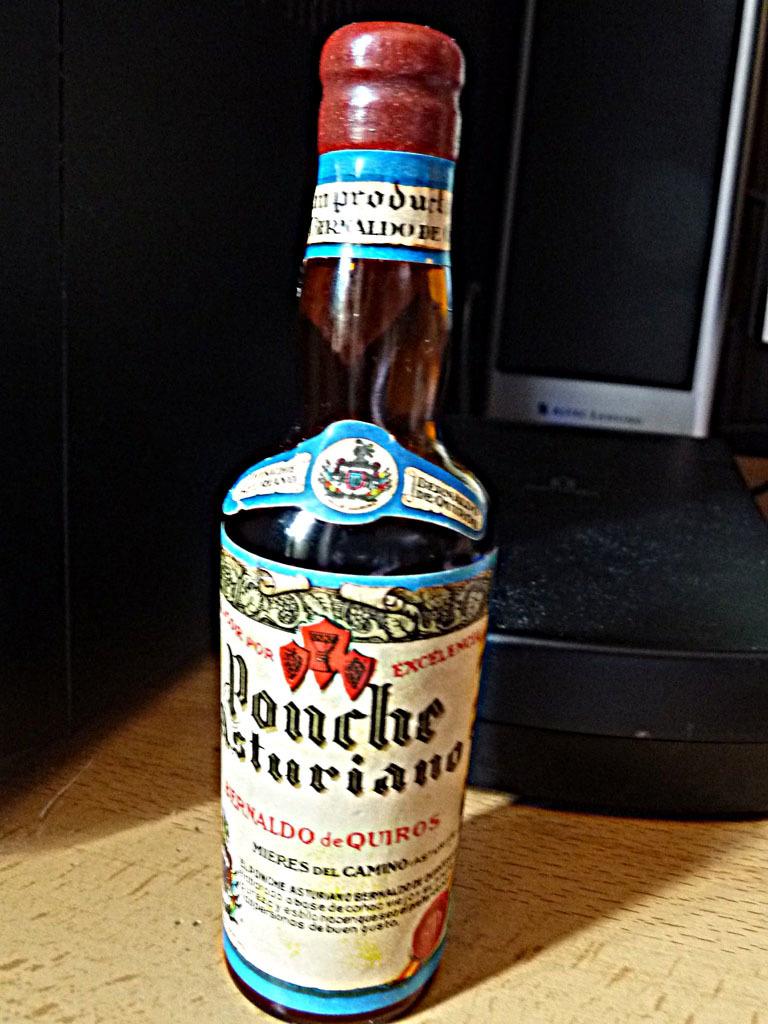What brand of alcohol is this?
Make the answer very short. Ponche. 